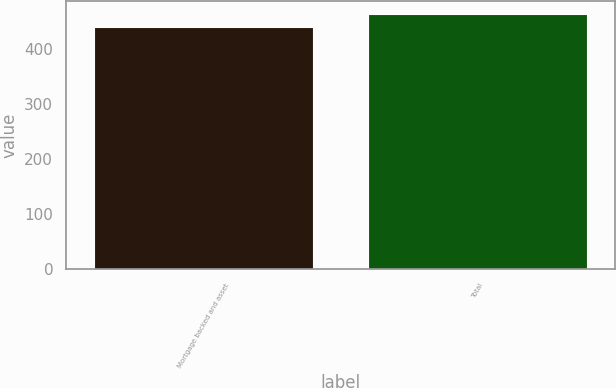<chart> <loc_0><loc_0><loc_500><loc_500><bar_chart><fcel>Mortgage backed and asset<fcel>Total<nl><fcel>440<fcel>464<nl></chart> 